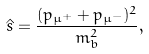Convert formula to latex. <formula><loc_0><loc_0><loc_500><loc_500>\hat { s } = \frac { ( p _ { \mu ^ { + } } + p _ { \mu ^ { - } } ) ^ { 2 } } { m _ { b } ^ { 2 } } ,</formula> 